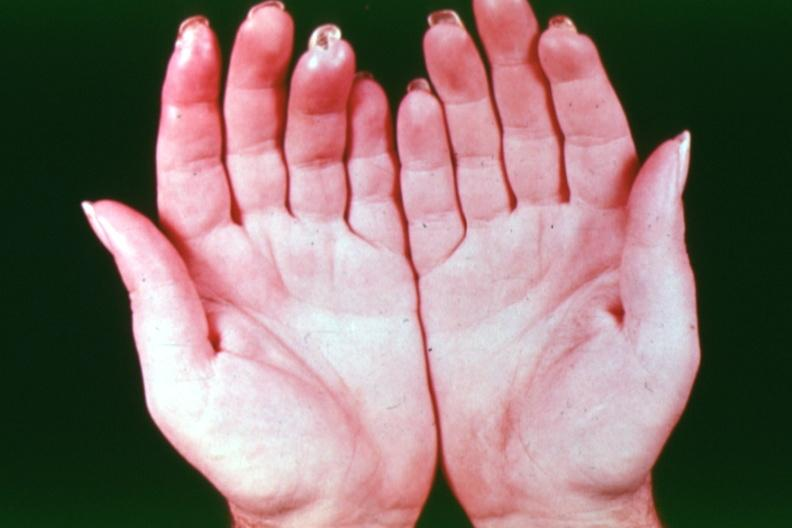what does this image show?
Answer the question using a single word or phrase. Gangrene buergers disease 